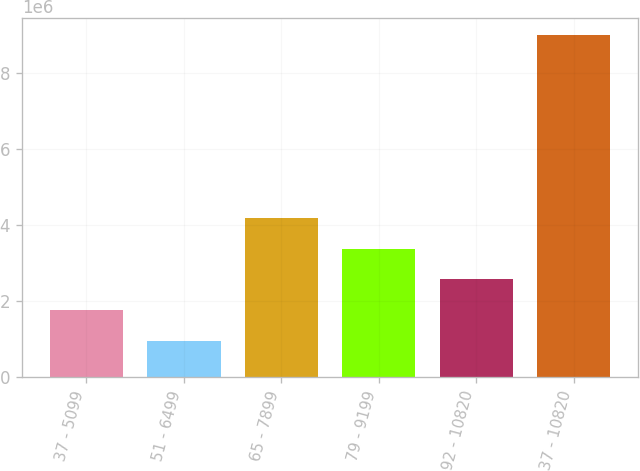Convert chart to OTSL. <chart><loc_0><loc_0><loc_500><loc_500><bar_chart><fcel>37 - 5099<fcel>51 - 6499<fcel>65 - 7899<fcel>79 - 9199<fcel>92 - 10820<fcel>37 - 10820<nl><fcel>1.77067e+06<fcel>966155<fcel>4.1842e+06<fcel>3.37969e+06<fcel>2.57518e+06<fcel>9.01126e+06<nl></chart> 